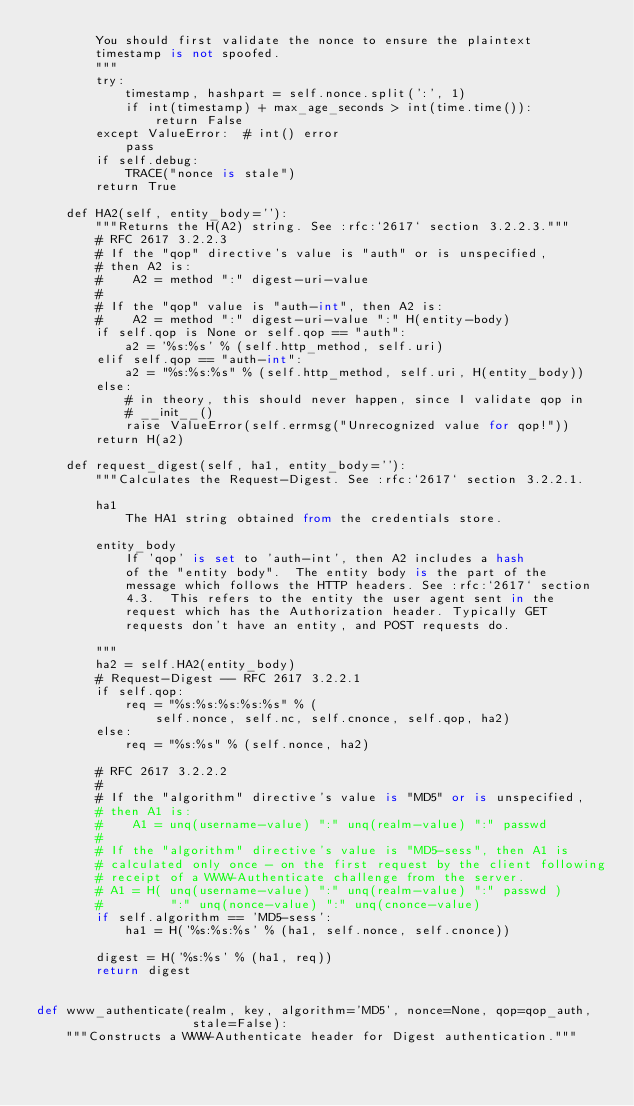<code> <loc_0><loc_0><loc_500><loc_500><_Python_>        You should first validate the nonce to ensure the plaintext
        timestamp is not spoofed.
        """
        try:
            timestamp, hashpart = self.nonce.split(':', 1)
            if int(timestamp) + max_age_seconds > int(time.time()):
                return False
        except ValueError:  # int() error
            pass
        if self.debug:
            TRACE("nonce is stale")
        return True

    def HA2(self, entity_body=''):
        """Returns the H(A2) string. See :rfc:`2617` section 3.2.2.3."""
        # RFC 2617 3.2.2.3
        # If the "qop" directive's value is "auth" or is unspecified,
        # then A2 is:
        #    A2 = method ":" digest-uri-value
        #
        # If the "qop" value is "auth-int", then A2 is:
        #    A2 = method ":" digest-uri-value ":" H(entity-body)
        if self.qop is None or self.qop == "auth":
            a2 = '%s:%s' % (self.http_method, self.uri)
        elif self.qop == "auth-int":
            a2 = "%s:%s:%s" % (self.http_method, self.uri, H(entity_body))
        else:
            # in theory, this should never happen, since I validate qop in
            # __init__()
            raise ValueError(self.errmsg("Unrecognized value for qop!"))
        return H(a2)

    def request_digest(self, ha1, entity_body=''):
        """Calculates the Request-Digest. See :rfc:`2617` section 3.2.2.1.

        ha1
            The HA1 string obtained from the credentials store.

        entity_body
            If 'qop' is set to 'auth-int', then A2 includes a hash
            of the "entity body".  The entity body is the part of the
            message which follows the HTTP headers. See :rfc:`2617` section
            4.3.  This refers to the entity the user agent sent in the
            request which has the Authorization header. Typically GET
            requests don't have an entity, and POST requests do.

        """
        ha2 = self.HA2(entity_body)
        # Request-Digest -- RFC 2617 3.2.2.1
        if self.qop:
            req = "%s:%s:%s:%s:%s" % (
                self.nonce, self.nc, self.cnonce, self.qop, ha2)
        else:
            req = "%s:%s" % (self.nonce, ha2)

        # RFC 2617 3.2.2.2
        #
        # If the "algorithm" directive's value is "MD5" or is unspecified,
        # then A1 is:
        #    A1 = unq(username-value) ":" unq(realm-value) ":" passwd
        #
        # If the "algorithm" directive's value is "MD5-sess", then A1 is
        # calculated only once - on the first request by the client following
        # receipt of a WWW-Authenticate challenge from the server.
        # A1 = H( unq(username-value) ":" unq(realm-value) ":" passwd )
        #         ":" unq(nonce-value) ":" unq(cnonce-value)
        if self.algorithm == 'MD5-sess':
            ha1 = H('%s:%s:%s' % (ha1, self.nonce, self.cnonce))

        digest = H('%s:%s' % (ha1, req))
        return digest


def www_authenticate(realm, key, algorithm='MD5', nonce=None, qop=qop_auth,
                     stale=False):
    """Constructs a WWW-Authenticate header for Digest authentication."""</code> 